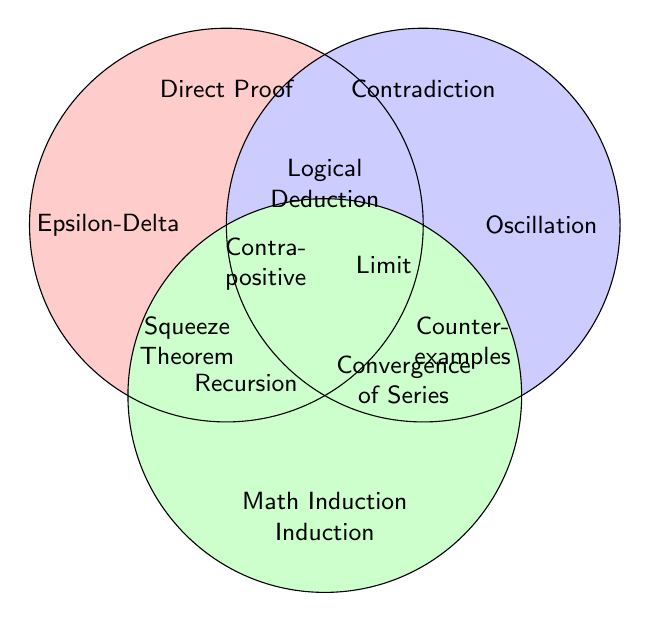What element is located at the intersection of all three circles? The element located at the intersection of all three circles is found at the region where the circles of Direct Proof, Contradiction, and Induction overlap. This specific element is "Logical Deduction."
Answer: Logical Deduction Which method is associated with Epsilon-Delta Proofs? To determine which method is associated with Epsilon-Delta Proofs, locate where Epsilon-Delta is situated. It resides only within the Direct Proof circle and does not intersect with others.
Answer: Direct Proof Which method(s) are used for proving the Convergence of Series? To find the methods for proving the Convergence of Series, identify the location of the element. It resides where the circles of Contradiction and Induction overlap.
Answer: Contradiction, Induction How many elements are unique to the Proof by Induction method? Identify the elements solely within the Induction circle and not overlapping with others. These elements include "Mathematical Induction" and "Recursion."
Answer: 2 Which element is shared by Direct Proof and Contradiction, but not by Induction? Identify the region where the circles of Direct Proof and Contradiction overlap, but not with Induction. The elements in this region are "Limit Properties," "Contrapositive Arguments," and "Squeeze Theorem."
Answer: Limit Properties, Contrapositive Arguments, Squeeze Theorem Where is Oscillation Theorems located? Find the position of Oscillation Theorems by looking for its label. It is located only in the Contradiction circle.
Answer: Contradiction Are Counterexamples associated with Direct Proof? Locate "Counterexamples" and check if it falls within the Direct Proof circle. It does not and is only within the Contradiction circle.
Answer: No Which method(s) are used for Limit Properties? Identify the location of the element Limit Properties within the figure. It is shared between Direct Proof and Contradiction.
Answer: Direct Proof, Contradiction How many elements are common to Direct Proof and Proof by Contradiction? Count the elements in the overlapping region of Direct Proof and Contradiction circles. The elements here are "Logical Deduction," "Contrapositive Arguments," "Limit Properties," and "Squeeze Theorem."
Answer: 4 